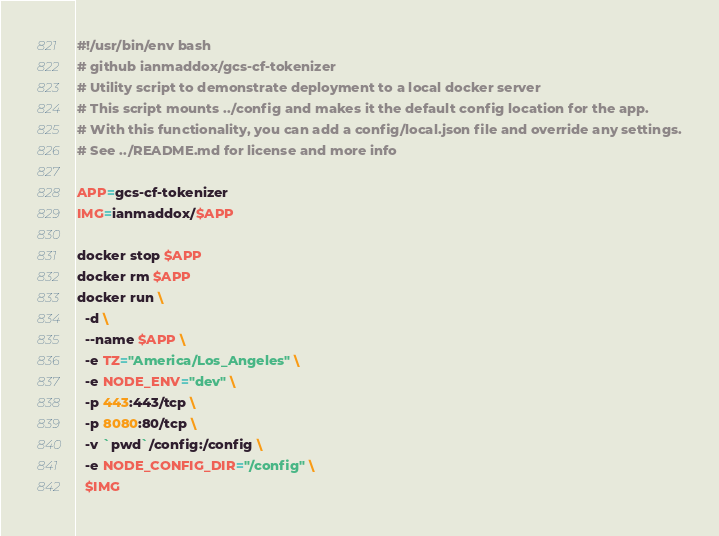Convert code to text. <code><loc_0><loc_0><loc_500><loc_500><_Bash_>#!/usr/bin/env bash
# github ianmaddox/gcs-cf-tokenizer
# Utility script to demonstrate deployment to a local docker server
# This script mounts ../config and makes it the default config location for the app.
# With this functionality, you can add a config/local.json file and override any settings.
# See ../README.md for license and more info

APP=gcs-cf-tokenizer
IMG=ianmaddox/$APP

docker stop $APP
docker rm $APP
docker run \
  -d \
  --name $APP \
  -e TZ="America/Los_Angeles" \
  -e NODE_ENV="dev" \
  -p 443:443/tcp \
  -p 8080:80/tcp \
  -v `pwd`/config:/config \
  -e NODE_CONFIG_DIR="/config" \
  $IMG
</code> 